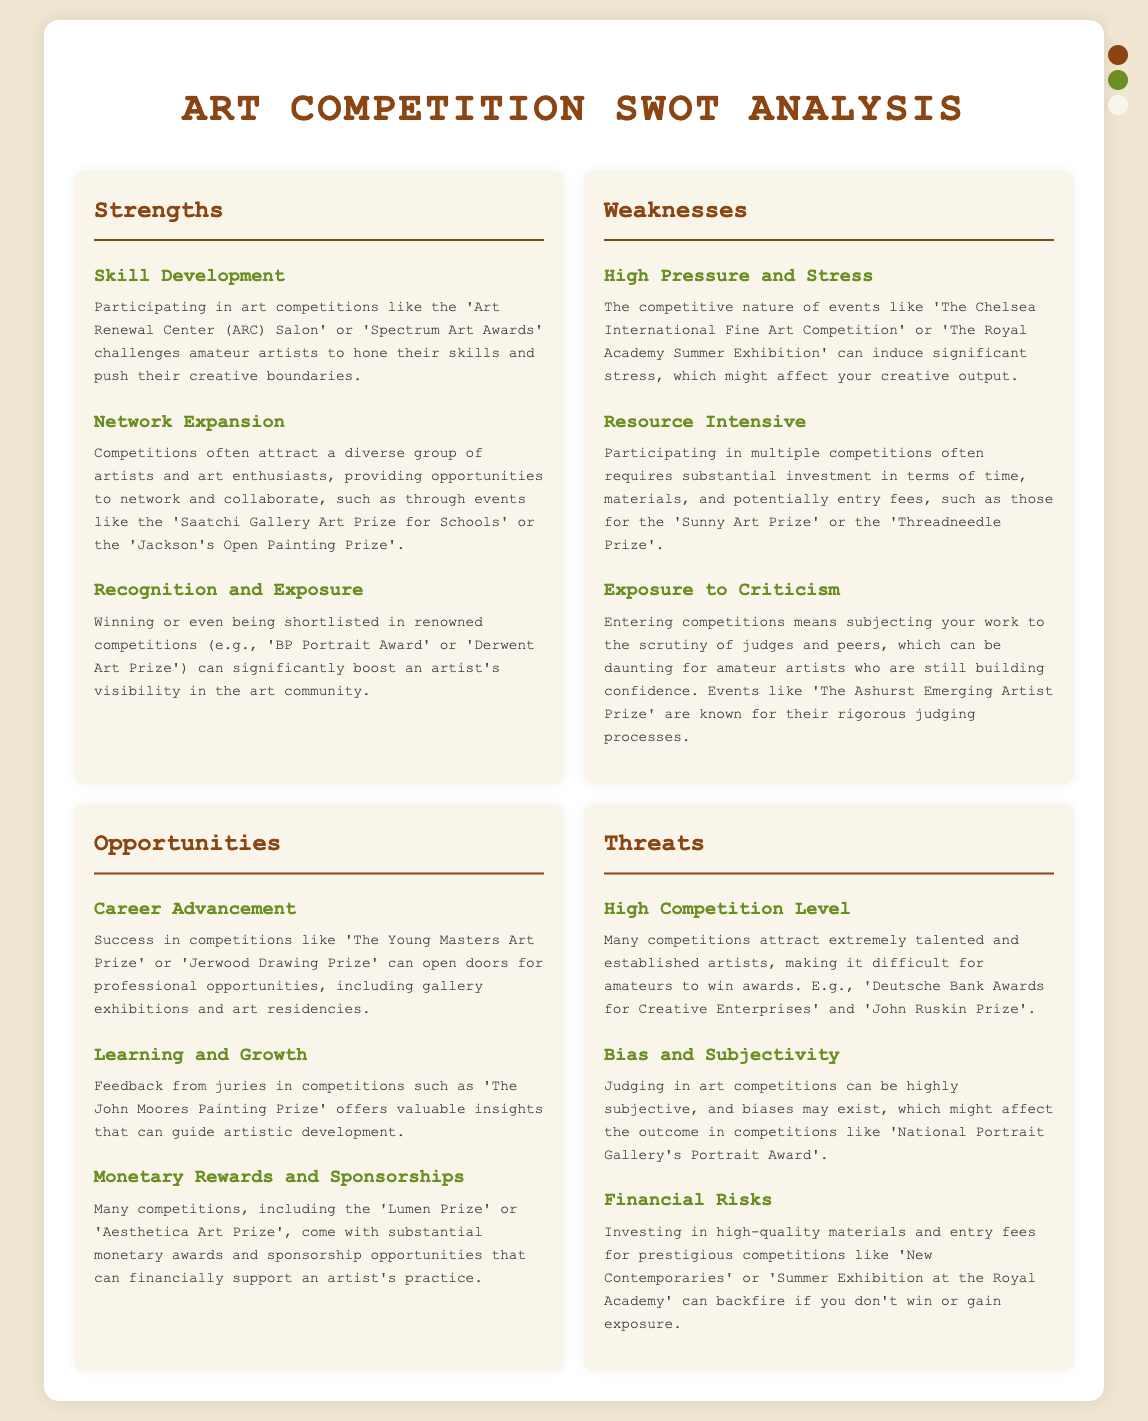What is one strength of participating in art competitions? The document lists several strengths, one of which is that competitions challenge amateur artists to hone their skills.
Answer: Skill Development What can competitions provide for amateur artists according to the document? The document mentions that competitions often attract a diverse group of artists, providing opportunities to network.
Answer: Network Expansion Which opportunity can arise from success in art competitions? The document states that success in competitions can open doors for professional opportunities, including gallery exhibitions.
Answer: Career Advancement What is a common threat mentioned for amateur artists in competitions? The document highlights that many competitions attract extremely talented and established artists, which can be daunting for amateurs.
Answer: High Competition Level Which weakness involves the potential for stress? The document describes the competitive nature of events that can induce significant stress for amateur artists.
Answer: High Pressure and Stress What is one form of support mentioned for artists participating in competitions? The document states that many competitions come with substantial monetary awards and sponsorship opportunities.
Answer: Monetary Rewards and Sponsorships How does the document define bias related to art competitions? The document notes that judging can be highly subjective and biases may exist, affecting outcomes.
Answer: Bias and Subjectivity What competition is specifically mentioned in relation to skill development? The document references 'Art Renewal Center (ARC) Salon' as a competition that challenges artists to improve their skills.
Answer: Art Renewal Center (ARC) Salon What feedback can artists receive from juries in competitions? According to the document, feedback from juries offers valuable insights that can guide artistic development.
Answer: Learning and Growth 